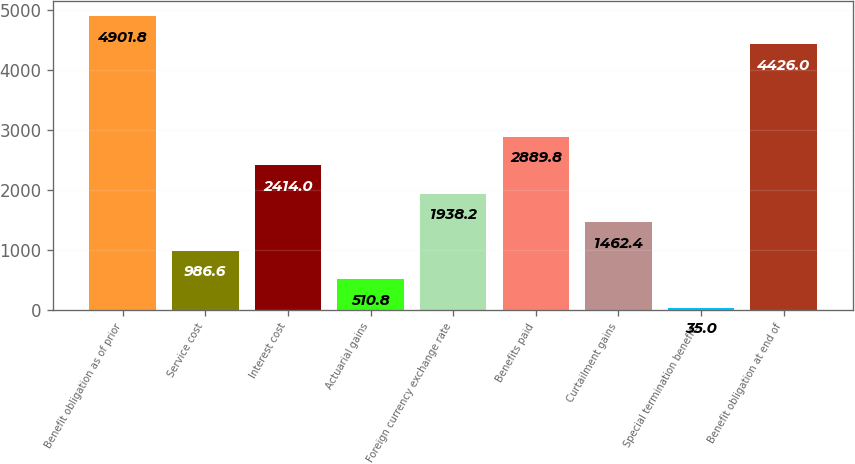Convert chart. <chart><loc_0><loc_0><loc_500><loc_500><bar_chart><fcel>Benefit obligation as of prior<fcel>Service cost<fcel>Interest cost<fcel>Actuarial gains<fcel>Foreign currency exchange rate<fcel>Benefits paid<fcel>Curtailment gains<fcel>Special termination benefits<fcel>Benefit obligation at end of<nl><fcel>4901.8<fcel>986.6<fcel>2414<fcel>510.8<fcel>1938.2<fcel>2889.8<fcel>1462.4<fcel>35<fcel>4426<nl></chart> 